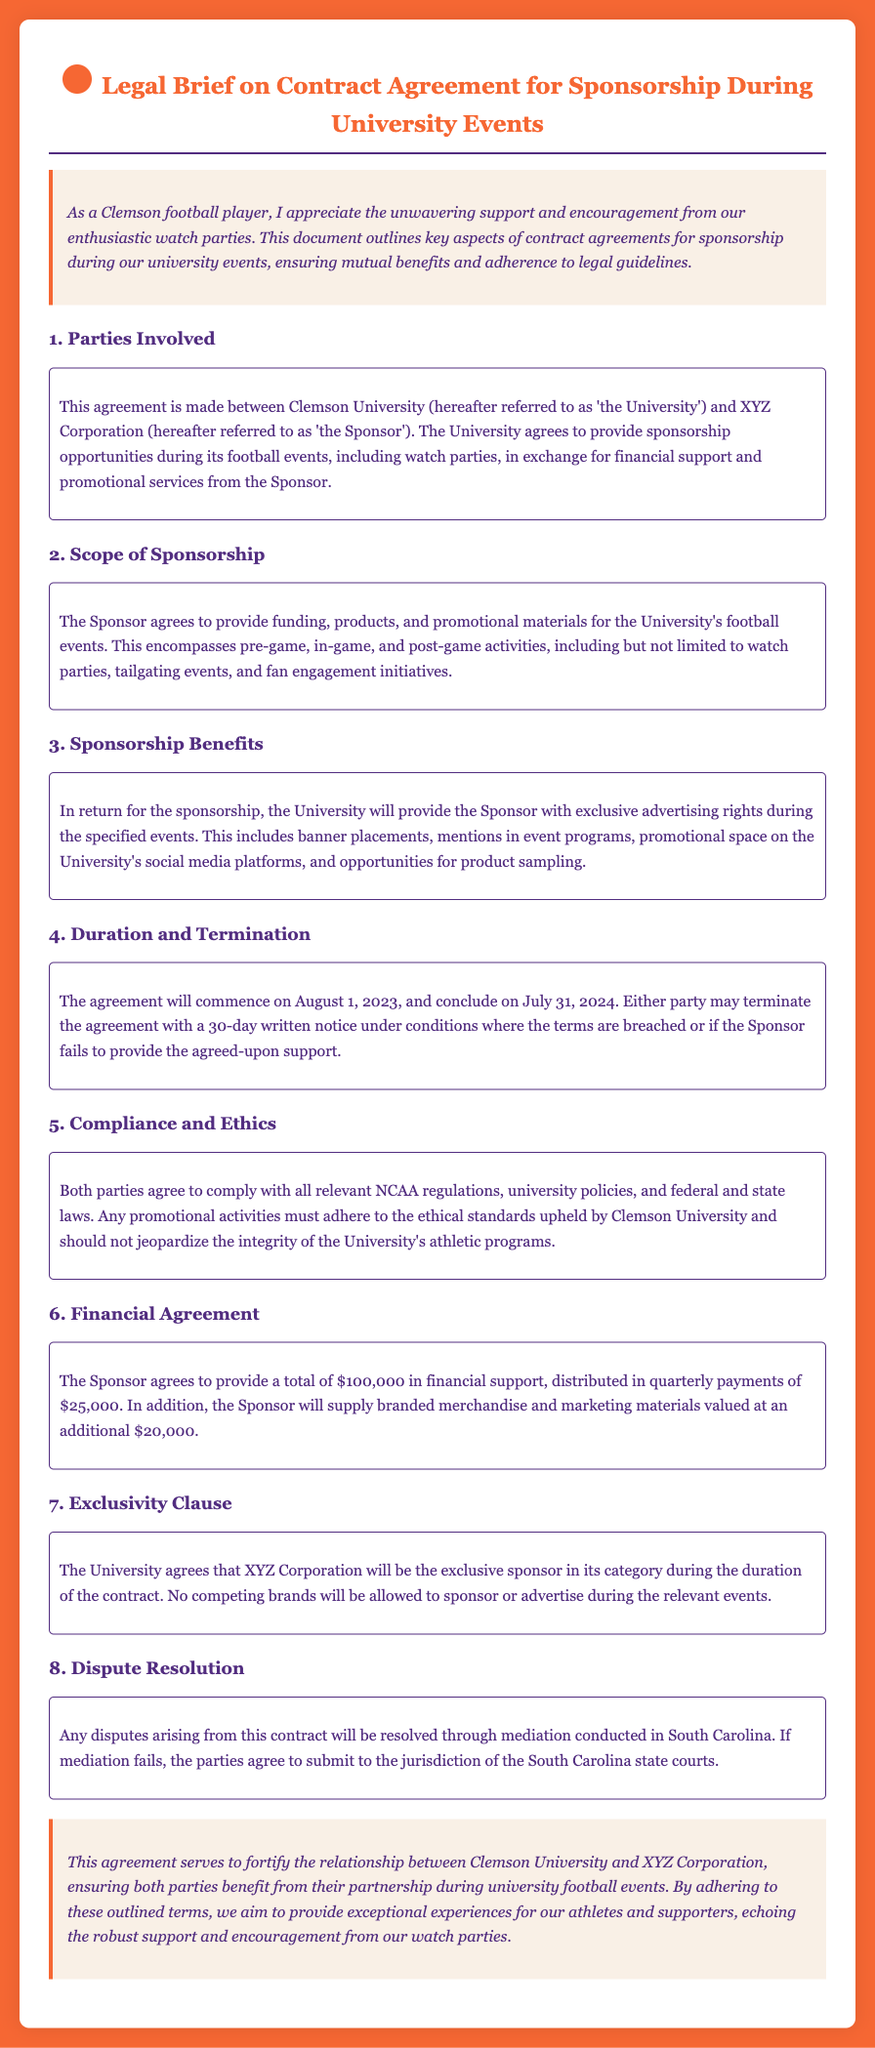What is the name of the University involved in the contract? The document identifies 'Clemson University' as the University involved in the contract agreement.
Answer: Clemson University Who is the Sponsor mentioned in the agreement? The agreement refers to 'XYZ Corporation' as the Sponsor.
Answer: XYZ Corporation What is the total financial support provided by the Sponsor? The document specifies that the Sponsor will provide a total of $100,000 in financial support.
Answer: $100,000 When does the agreement commence? The agreement states that it will commence on August 1, 2023.
Answer: August 1, 2023 What is the duration of the contract? The document mentions that the contract will last for one year, concluding on July 31, 2024.
Answer: one year What are the promotional opportunities for the Sponsor? The agreement outlines exclusive advertising rights, including banner placements and mentions in event programs as promotional opportunities.
Answer: exclusive advertising rights How much merchandise value will the Sponsor supply? The Sponsor will supply branded merchandise and marketing materials valued at an additional $20,000.
Answer: $20,000 Where will disputes be resolved if they arise? The document states that any disputes will be resolved through mediation conducted in South Carolina.
Answer: South Carolina What is the exclusivity clause in the agreement? The University agrees that XYZ Corporation will be the exclusive sponsor in its category during the duration of the contract.
Answer: exclusive sponsor in its category 